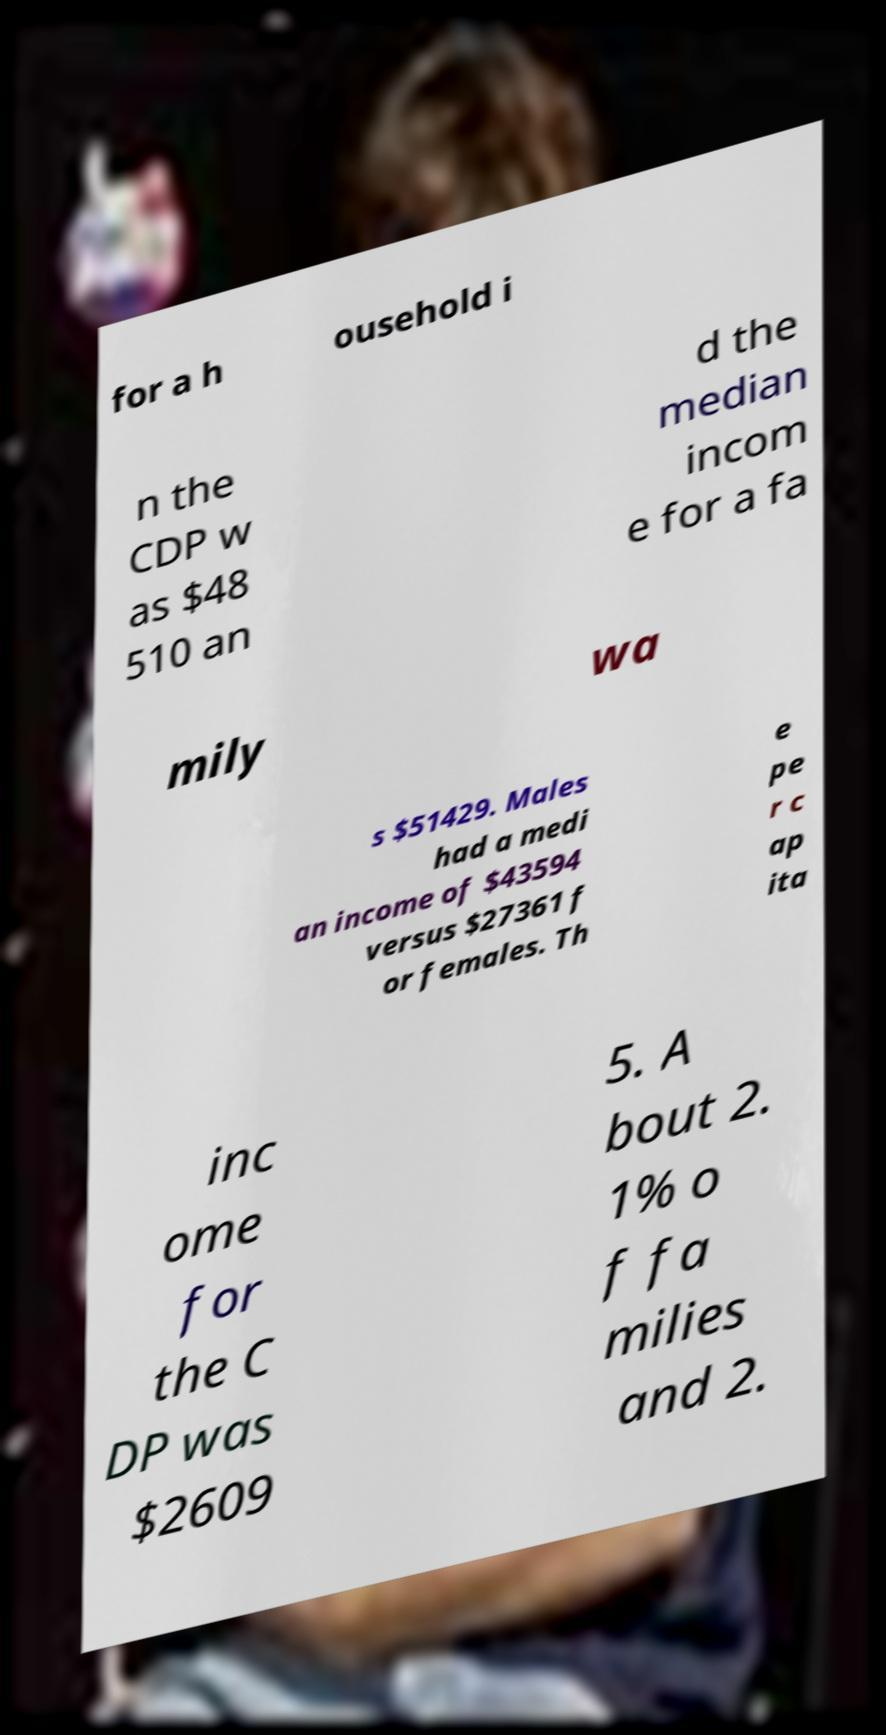I need the written content from this picture converted into text. Can you do that? for a h ousehold i n the CDP w as $48 510 an d the median incom e for a fa mily wa s $51429. Males had a medi an income of $43594 versus $27361 f or females. Th e pe r c ap ita inc ome for the C DP was $2609 5. A bout 2. 1% o f fa milies and 2. 